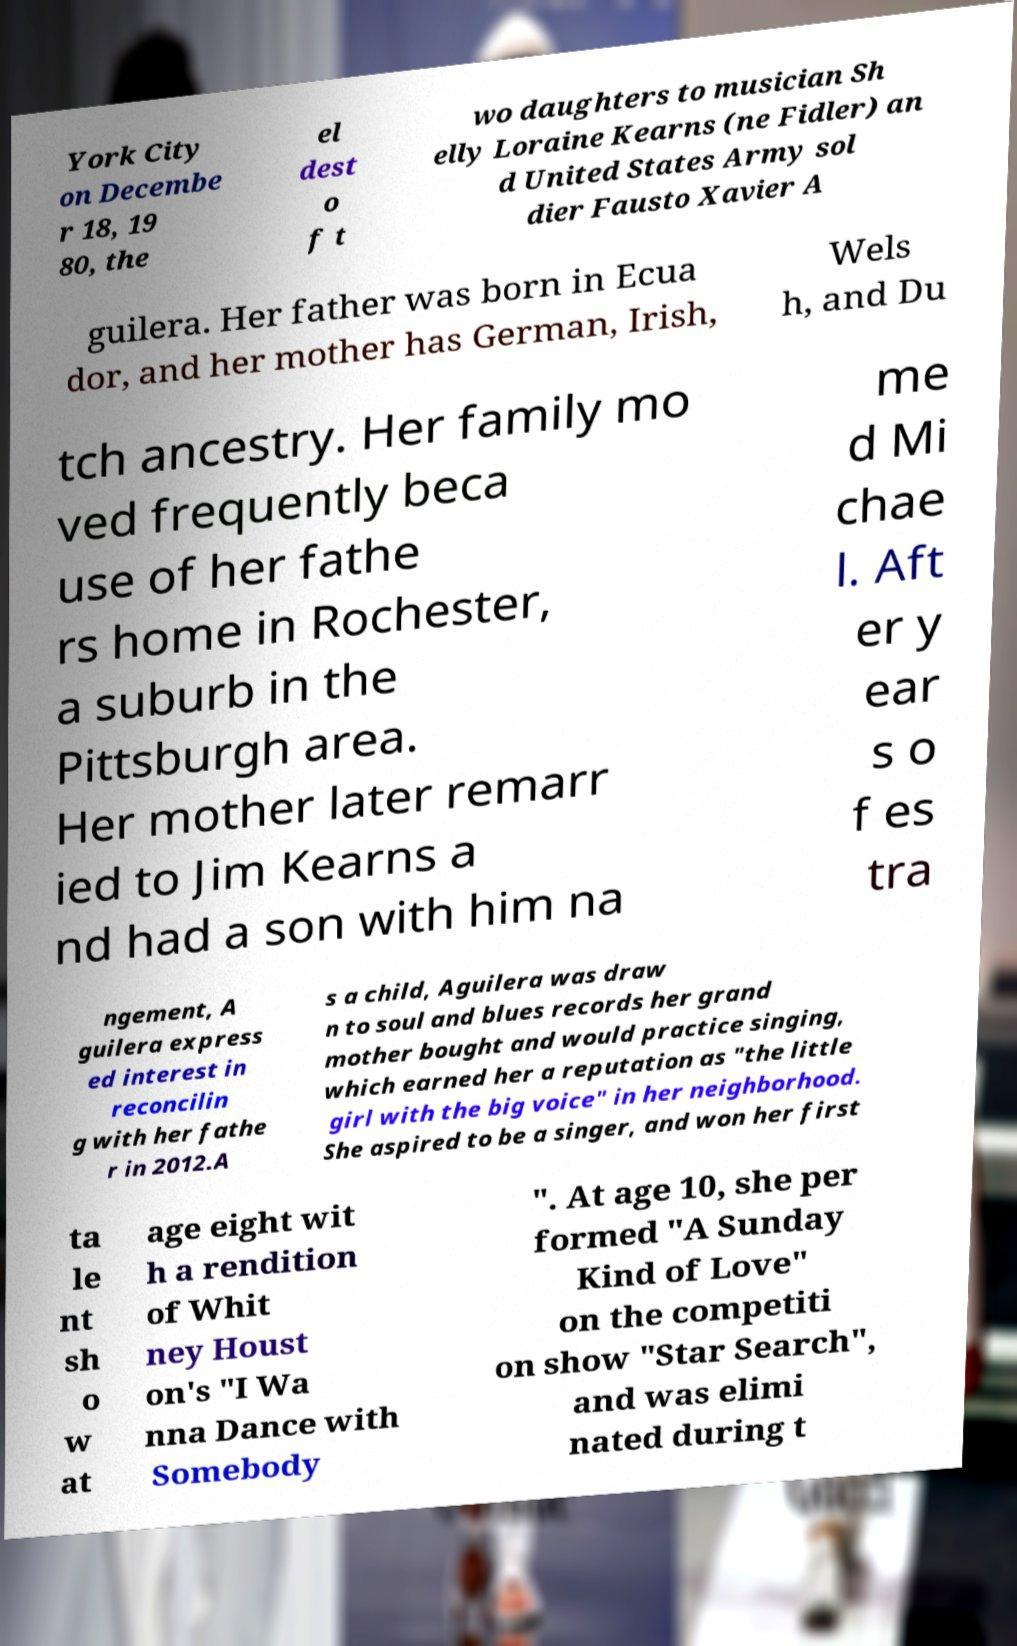Could you assist in decoding the text presented in this image and type it out clearly? York City on Decembe r 18, 19 80, the el dest o f t wo daughters to musician Sh elly Loraine Kearns (ne Fidler) an d United States Army sol dier Fausto Xavier A guilera. Her father was born in Ecua dor, and her mother has German, Irish, Wels h, and Du tch ancestry. Her family mo ved frequently beca use of her fathe rs home in Rochester, a suburb in the Pittsburgh area. Her mother later remarr ied to Jim Kearns a nd had a son with him na me d Mi chae l. Aft er y ear s o f es tra ngement, A guilera express ed interest in reconcilin g with her fathe r in 2012.A s a child, Aguilera was draw n to soul and blues records her grand mother bought and would practice singing, which earned her a reputation as "the little girl with the big voice" in her neighborhood. She aspired to be a singer, and won her first ta le nt sh o w at age eight wit h a rendition of Whit ney Houst on's "I Wa nna Dance with Somebody ". At age 10, she per formed "A Sunday Kind of Love" on the competiti on show "Star Search", and was elimi nated during t 